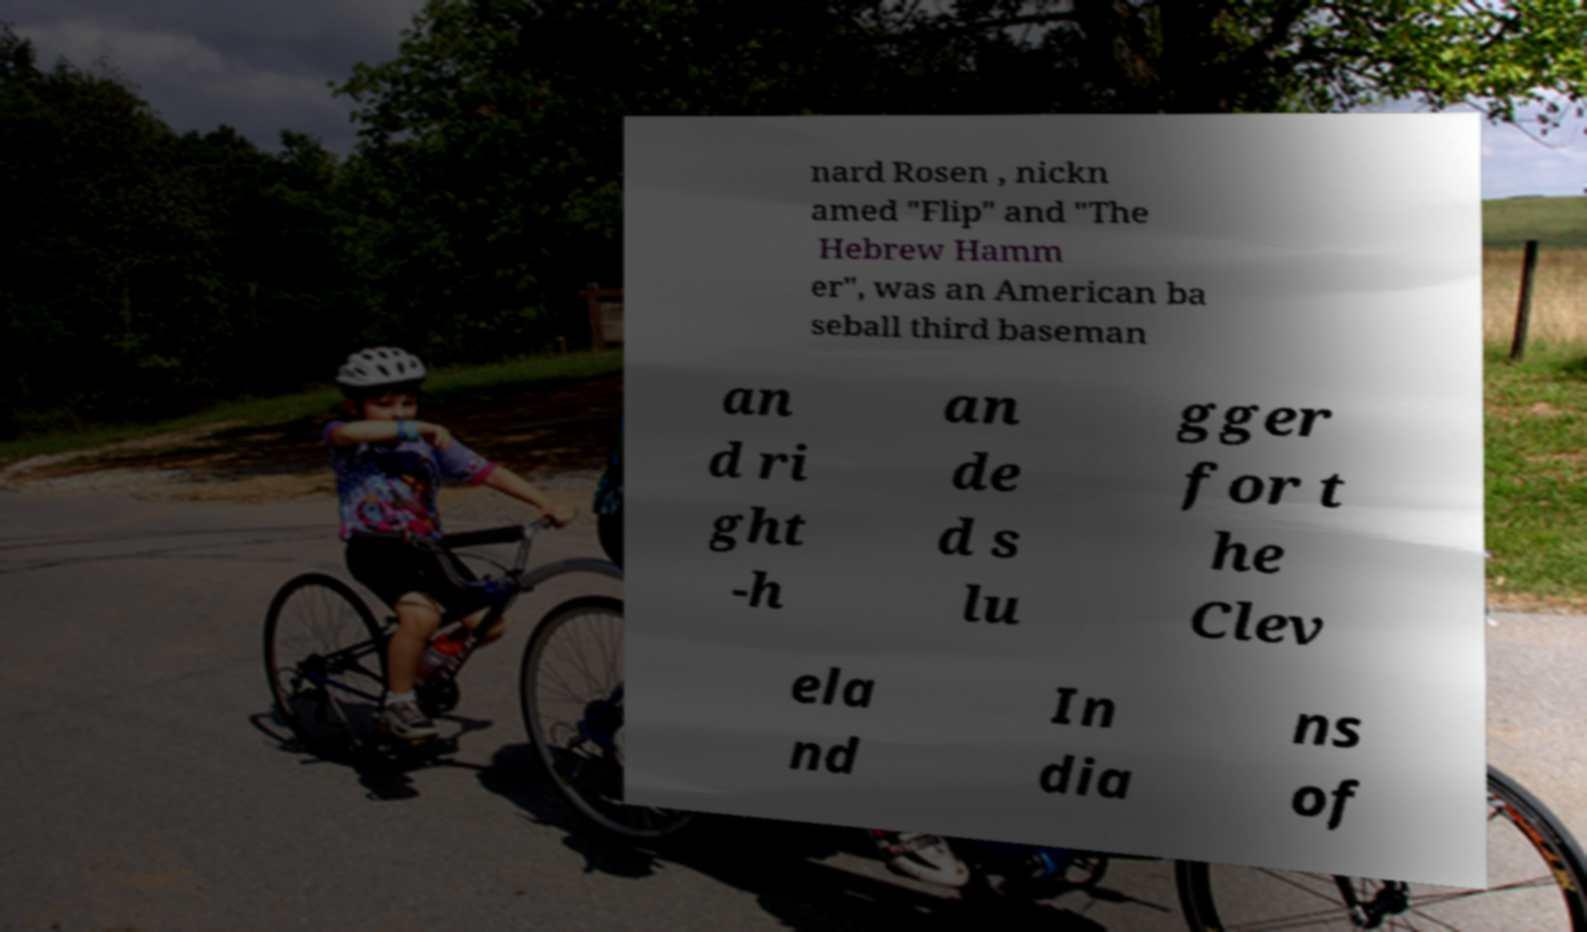Please identify and transcribe the text found in this image. nard Rosen , nickn amed "Flip" and "The Hebrew Hamm er", was an American ba seball third baseman an d ri ght -h an de d s lu gger for t he Clev ela nd In dia ns of 